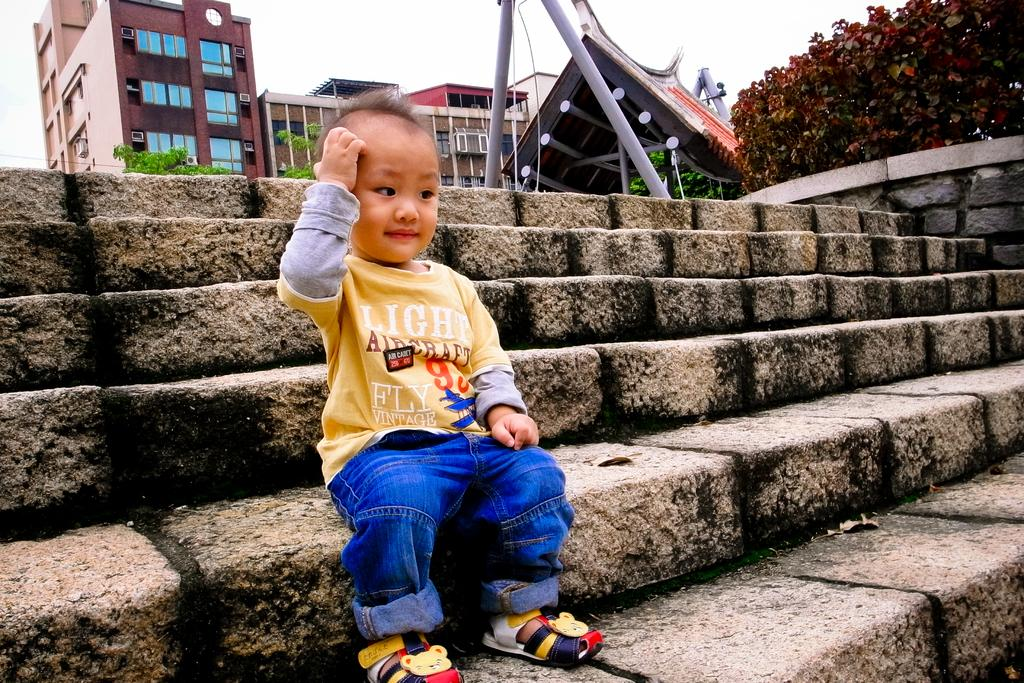What is the main subject of the image? There is a kid in the image. What can be seen in the background of the image? The sky is visible in the background of the image. What architectural features are present in the image? There are steps and buildings in the image. What type of natural elements can be seen in the image? There are plants in the image. How many pizzas are being delivered to the kid in the image? There are no pizzas visible in the image. What need does the kid have in the image? There is no indication of any specific need in the image. 